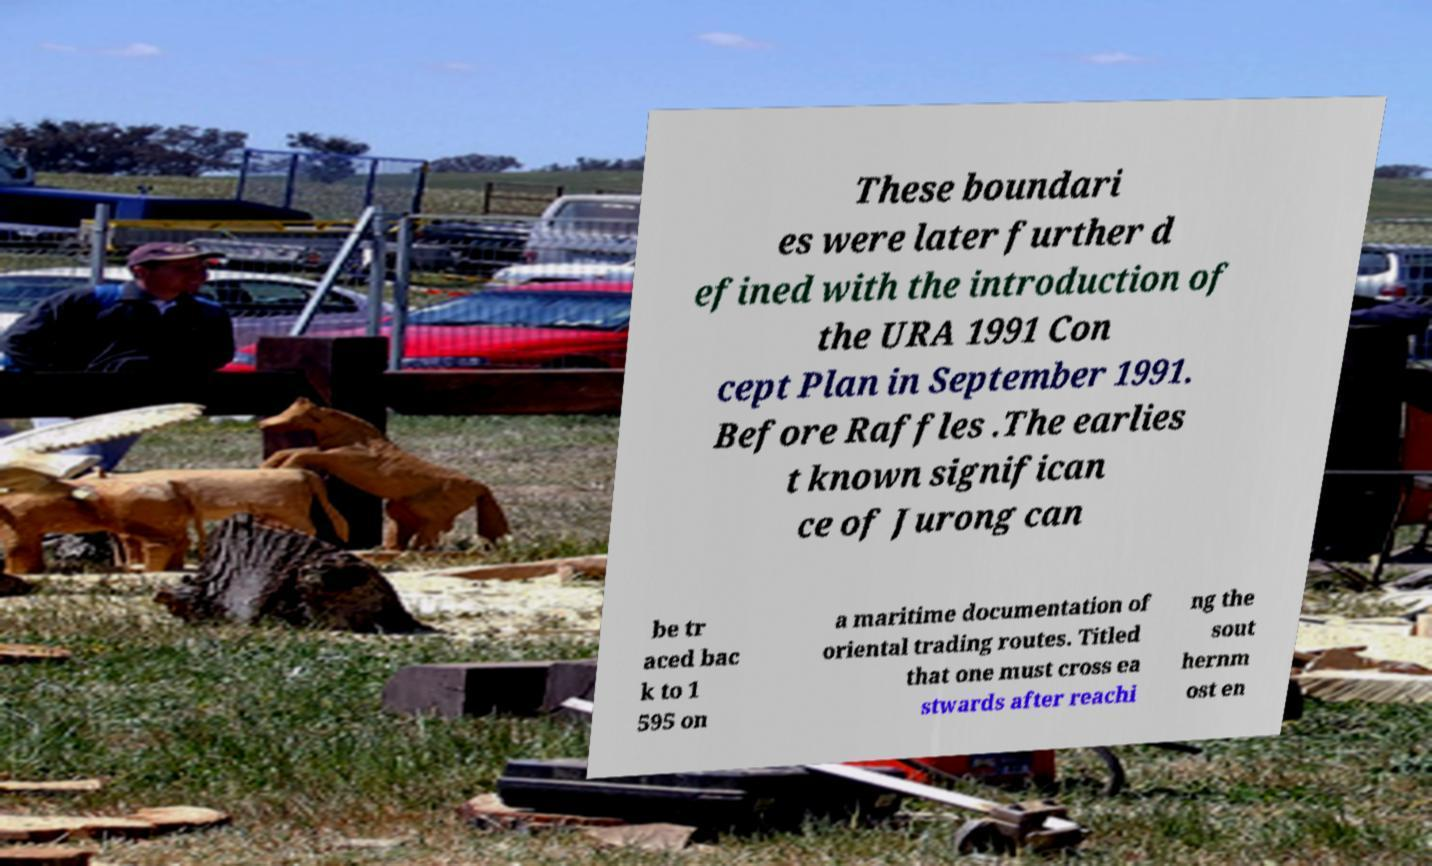Can you read and provide the text displayed in the image?This photo seems to have some interesting text. Can you extract and type it out for me? These boundari es were later further d efined with the introduction of the URA 1991 Con cept Plan in September 1991. Before Raffles .The earlies t known significan ce of Jurong can be tr aced bac k to 1 595 on a maritime documentation of oriental trading routes. Titled that one must cross ea stwards after reachi ng the sout hernm ost en 